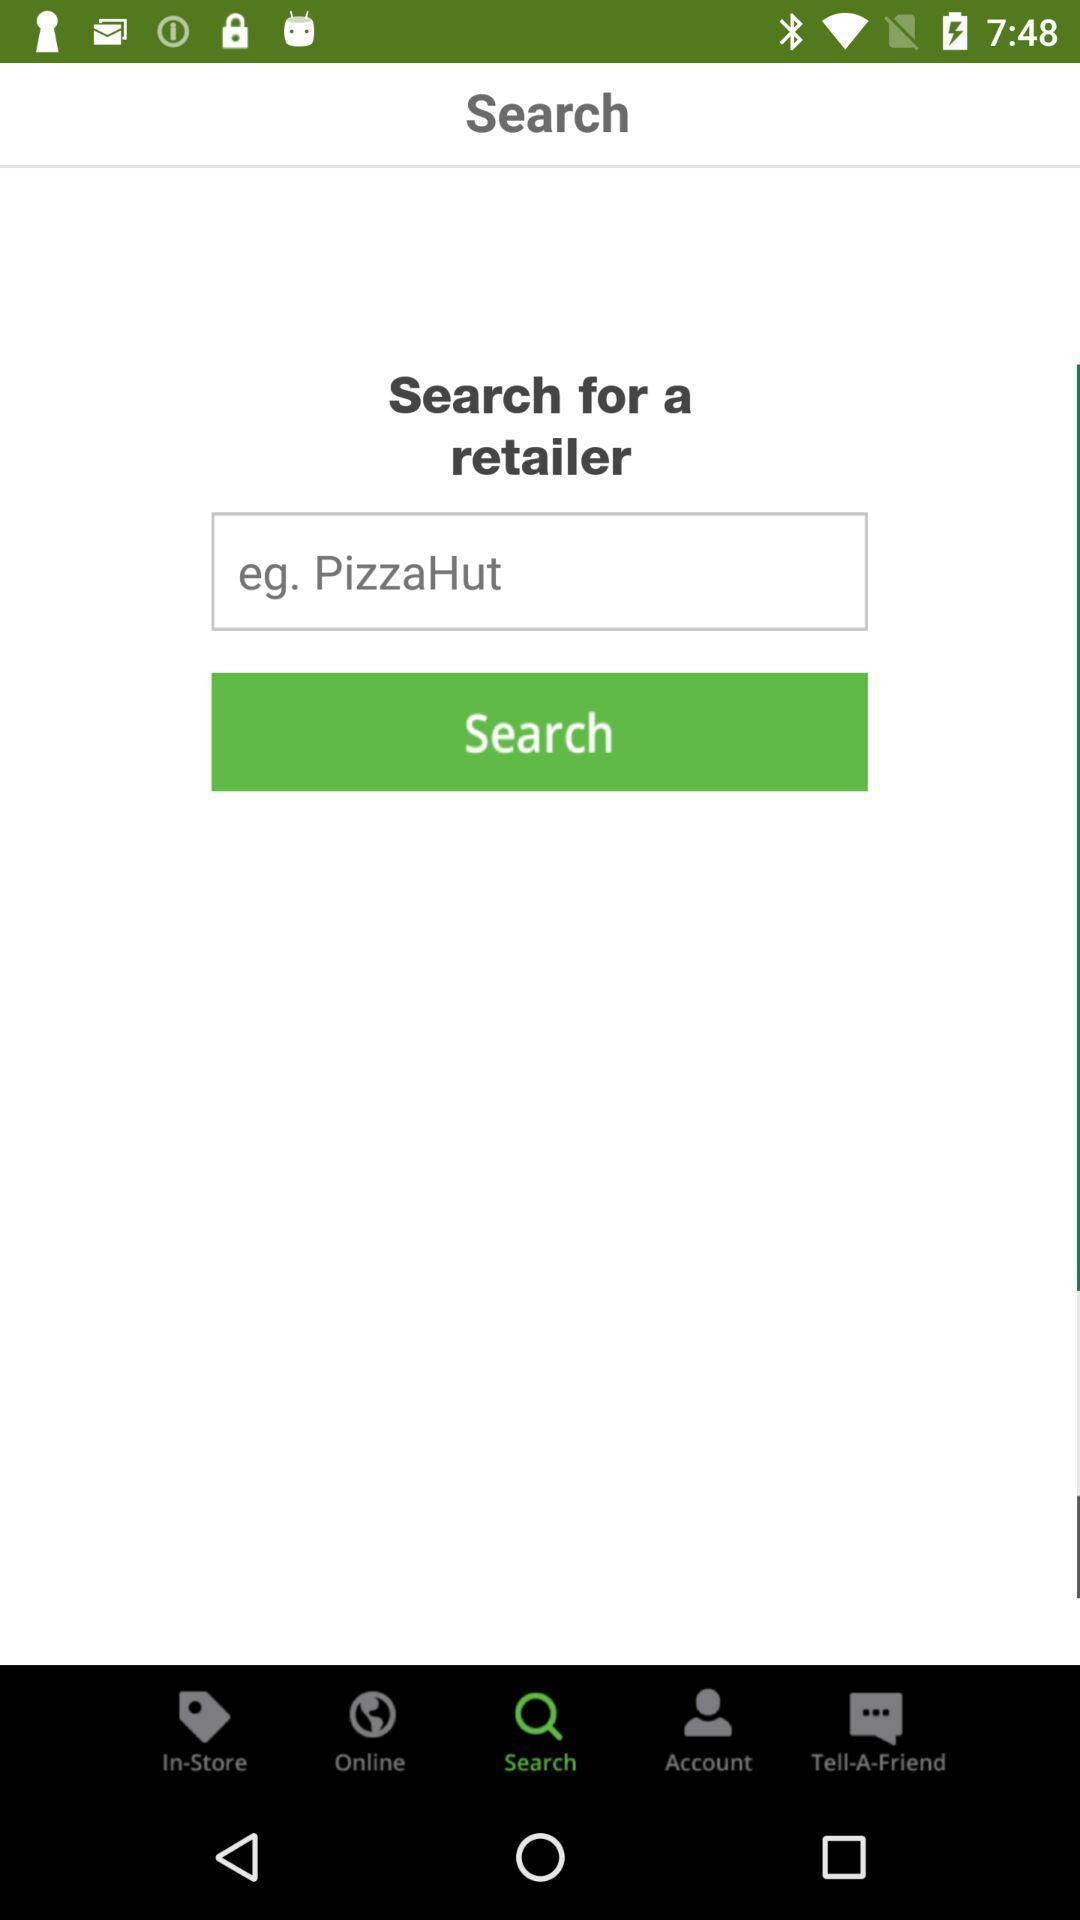Explain what's happening in this screen capture. Search bar to search for retailer in app. 